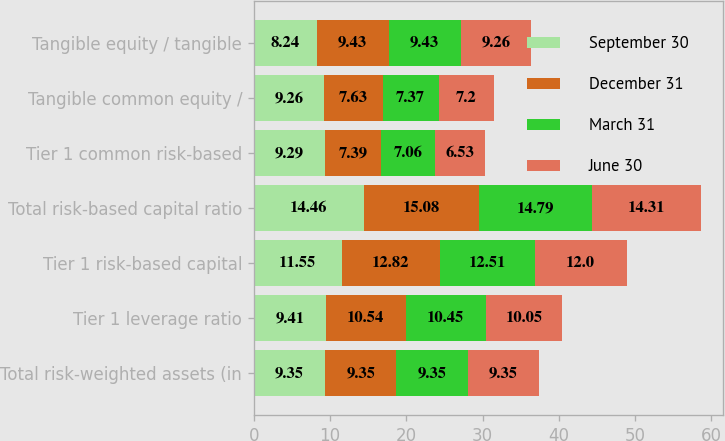Convert chart. <chart><loc_0><loc_0><loc_500><loc_500><stacked_bar_chart><ecel><fcel>Total risk-weighted assets (in<fcel>Tier 1 leverage ratio<fcel>Tier 1 risk-based capital<fcel>Total risk-based capital ratio<fcel>Tier 1 common risk-based<fcel>Tangible common equity /<fcel>Tangible equity / tangible<nl><fcel>September 30<fcel>9.35<fcel>9.41<fcel>11.55<fcel>14.46<fcel>9.29<fcel>9.26<fcel>8.24<nl><fcel>December 31<fcel>9.35<fcel>10.54<fcel>12.82<fcel>15.08<fcel>7.39<fcel>7.63<fcel>9.43<nl><fcel>March 31<fcel>9.35<fcel>10.45<fcel>12.51<fcel>14.79<fcel>7.06<fcel>7.37<fcel>9.43<nl><fcel>June 30<fcel>9.35<fcel>10.05<fcel>12<fcel>14.31<fcel>6.53<fcel>7.2<fcel>9.26<nl></chart> 